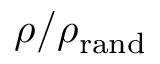Convert formula to latex. <formula><loc_0><loc_0><loc_500><loc_500>\rho / \rho _ { r a n d }</formula> 